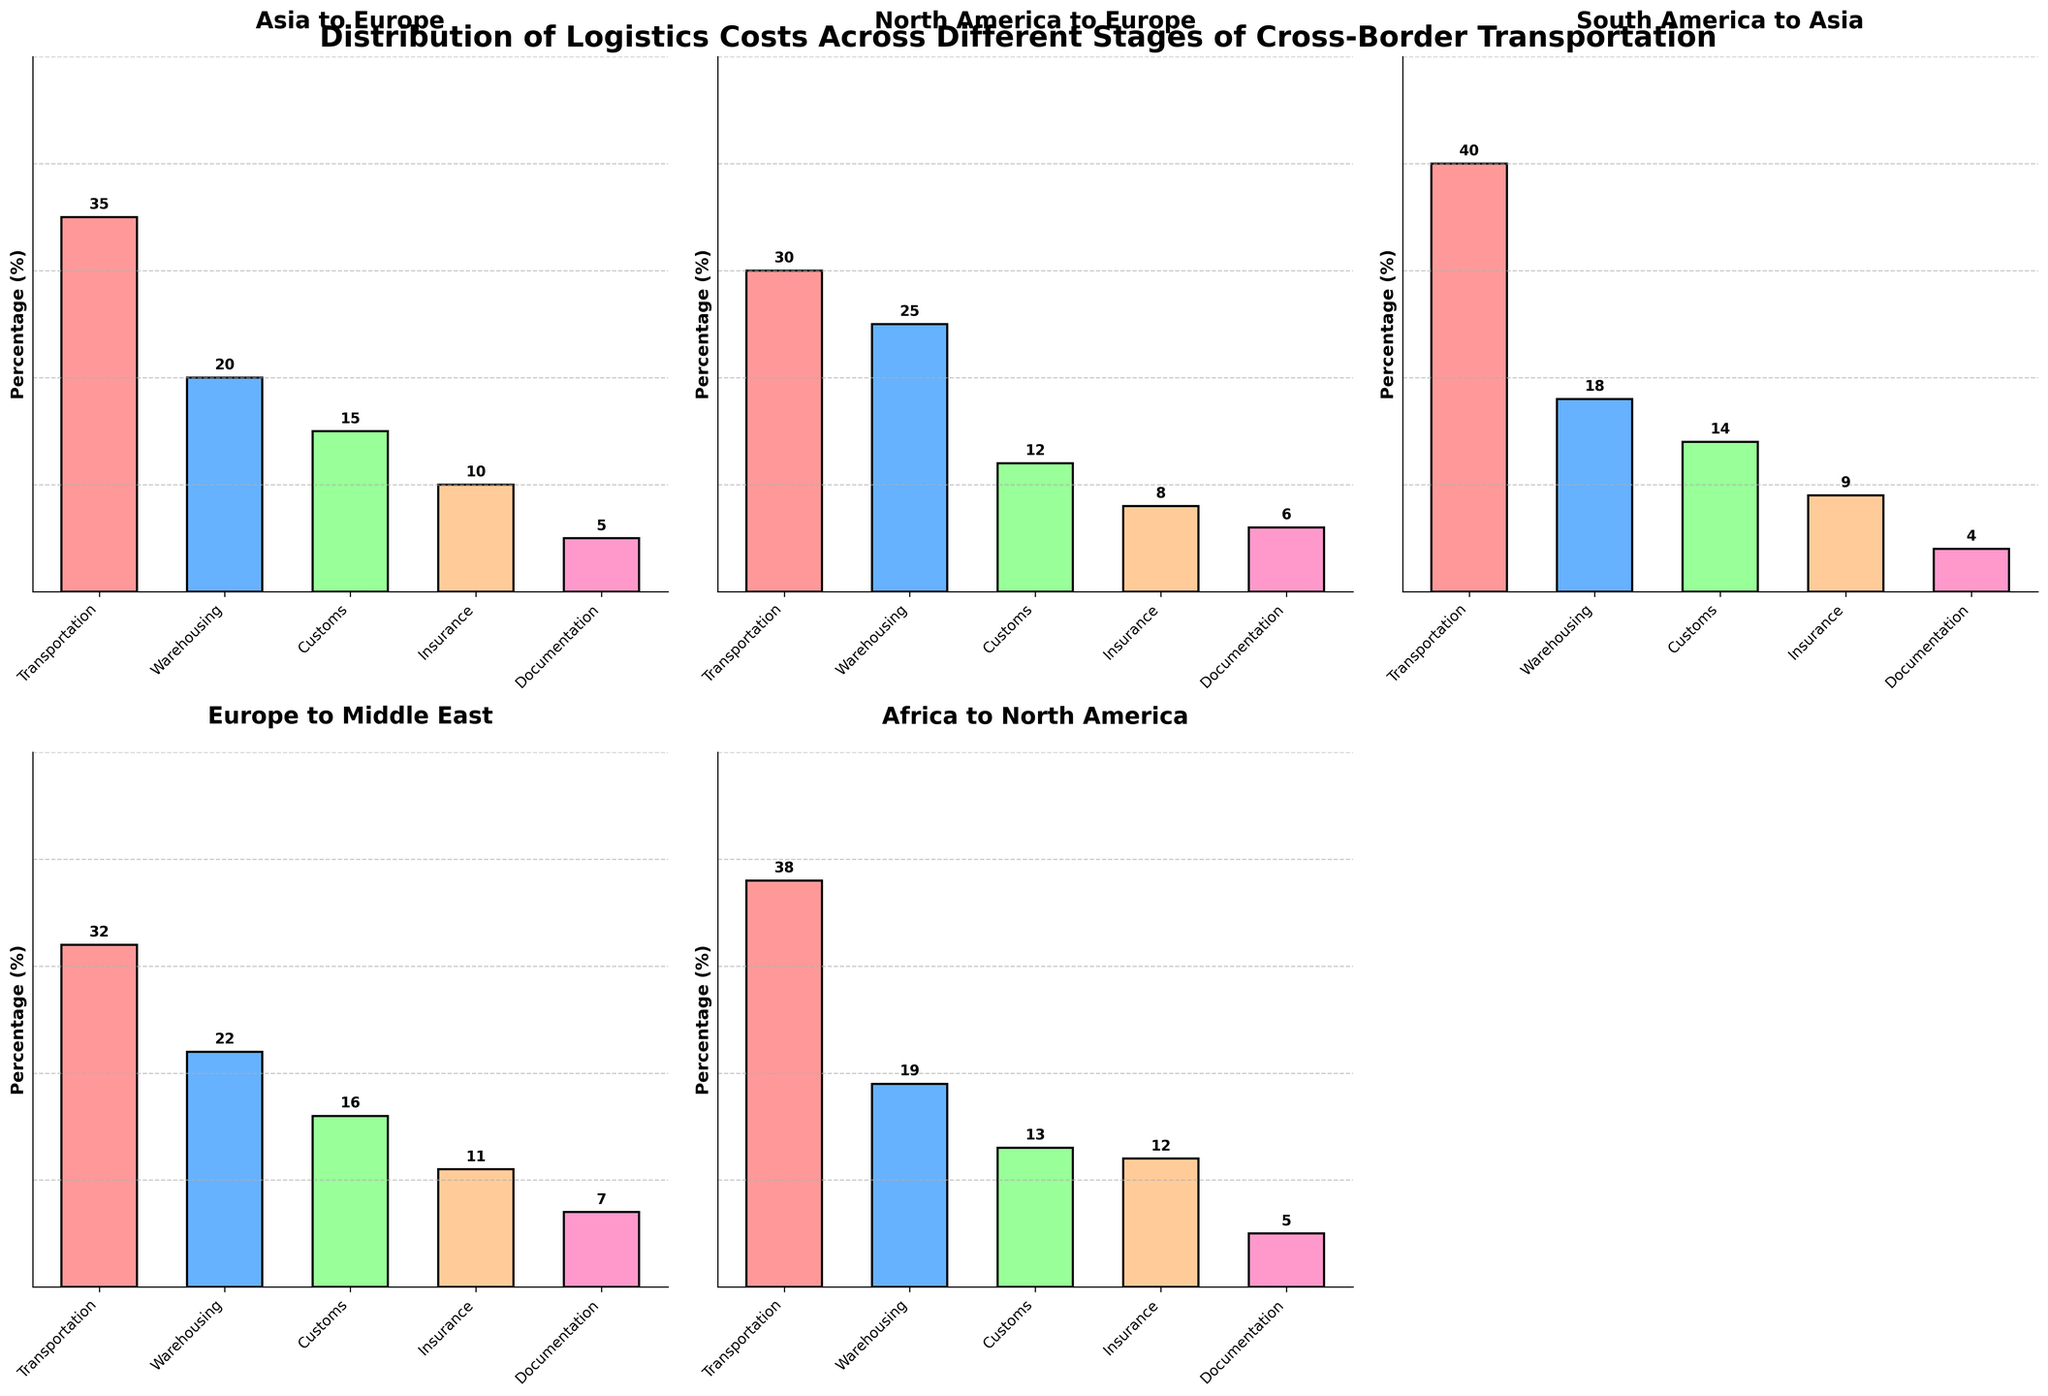How are the logistics costs distributed across the stages for the trade route from Asia to Europe? The bar chart for the trade route from Asia to Europe shows the percentage distribution of costs among different stages: Transportation, Warehousing, Customs, Insurance, and Documentation. The respective percentages are 35%, 20%, 15%, 10%, and 5%.
Answer: 35%, 20%, 15%, 10%, 5% Which trade route has the highest transportation cost? By examining each subplot, the highest transportation cost is for the Oceania to Europe trade route, which is 42%.
Answer: Oceania to Europe What is the combined cost of Warehousing and Insurance for Europe to Middle East? For the Europe to Middle East trade route, Warehousing is 22% and Insurance is 11%. Summing them up gives 22% + 11% = 33%.
Answer: 33% Which trade route has the lowest Customs cost and what is that value? The lowest Customs cost can be seen in the Oceania to Europe trade route, which is 11%.
Answer: Oceania to Europe How does the Transportation cost for North America to Europe compare to Africa to North America? The Transportation cost for North America to Europe is 30%, while for Africa to North America, it is 38%. Since 30% is less than 38%, the Transportation cost for North America to Europe is lower.
Answer: Lower What is the difference in the Documentation cost between South America to Asia and Europe to Middle East? The Documentation cost for South America to Asia is 4%, and for Europe to Middle East, it is 7%. The difference is 7% - 4% = 3%.
Answer: 3% Which stage has the most significant cost for the trade route from Africa to North America? The bar chart for Africa to North America shows that Transportation has the highest cost at 38%.
Answer: Transportation Are there any trade routes where Warehousing costs are higher than Transportation costs? By examining the bar charts, none of the trade routes have Warehousing costs higher than Transportation costs. All charts show Transportation costs being the highest among the stages.
Answer: No What is the average Customs cost across all trade routes presented? The Customs costs for the trade routes are: 15%, 12%, 14%, 16%, 13%, and 11%. The average can be found by summing these values and dividing by the number of trade routes: (15 + 12 + 14 + 16 + 13 + 11) / 6 = 81 / 6 = 13.5%.
Answer: 13.5% What is the total cost for all stages combined for North America to Europe? To find the total, sum all stage costs for North America to Europe: 30% (Transportation) + 25% (Warehousing) + 12% (Customs) + 8% (Insurance) + 6% (Documentation) = 81%.
Answer: 81% 